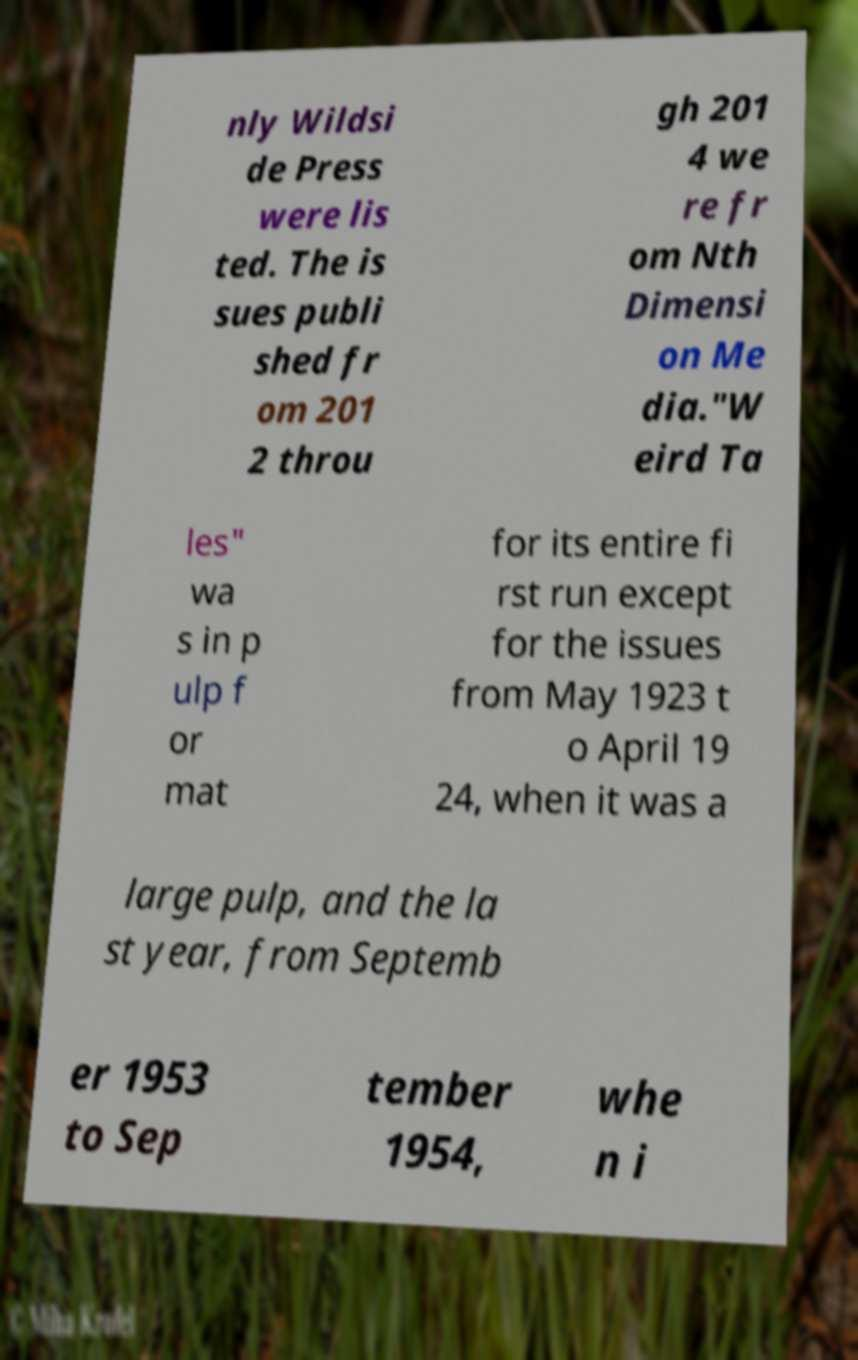Can you read and provide the text displayed in the image?This photo seems to have some interesting text. Can you extract and type it out for me? nly Wildsi de Press were lis ted. The is sues publi shed fr om 201 2 throu gh 201 4 we re fr om Nth Dimensi on Me dia."W eird Ta les" wa s in p ulp f or mat for its entire fi rst run except for the issues from May 1923 t o April 19 24, when it was a large pulp, and the la st year, from Septemb er 1953 to Sep tember 1954, whe n i 